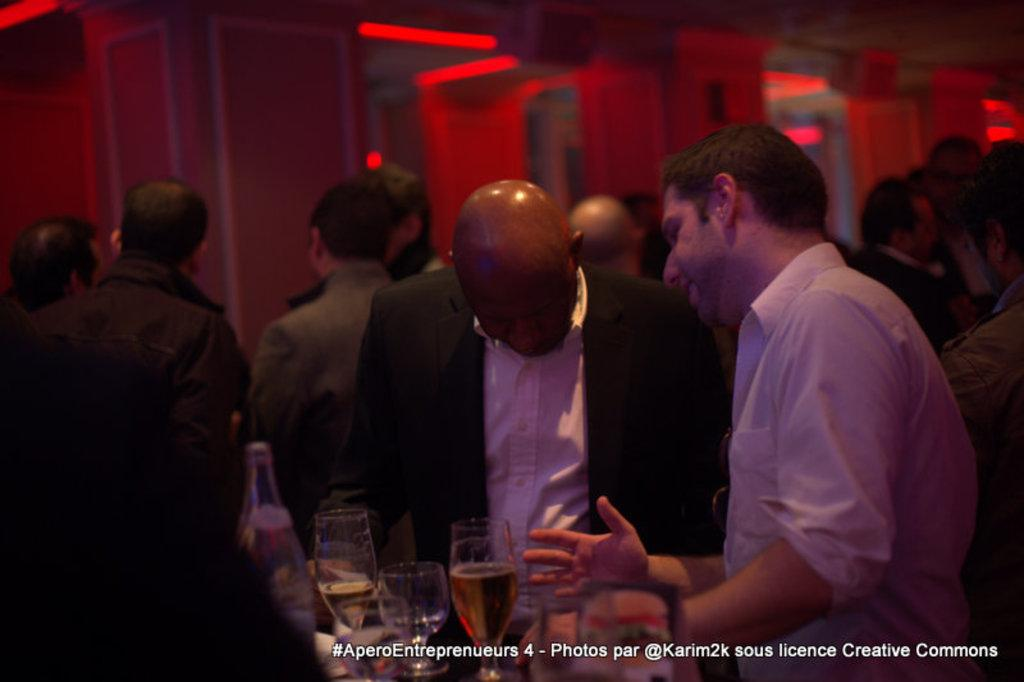Who or what can be seen in the image? There are people in the image. What objects are present that might be used for drinking? There are liquid-filled glasses in the image. What is the source of the liquid in the glasses? There is a bottle in the image. What architectural features can be seen in the background of the image? There are pillars in the background of the image. What can be seen illuminating the background of the image? There are lights in the background of the image. How does the rhythm of the music affect the people in the image? There is no mention of music or rhythm in the image, so we cannot determine how it affects the people. 